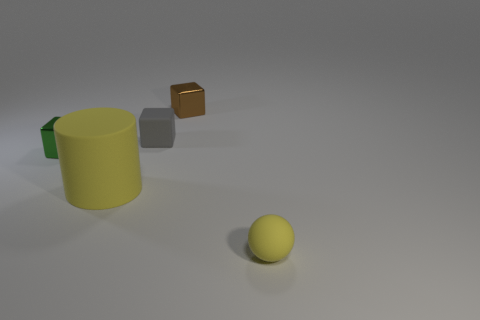Are there more tiny gray blocks that are to the right of the green metallic thing than blue objects? Yes, there are more tiny gray blocks to the right of the green cylindrical object than there are blue objects in the image. To be precise, there is only one tiny gray block visible to the right of the green object, while there are no blue objects present at all. 